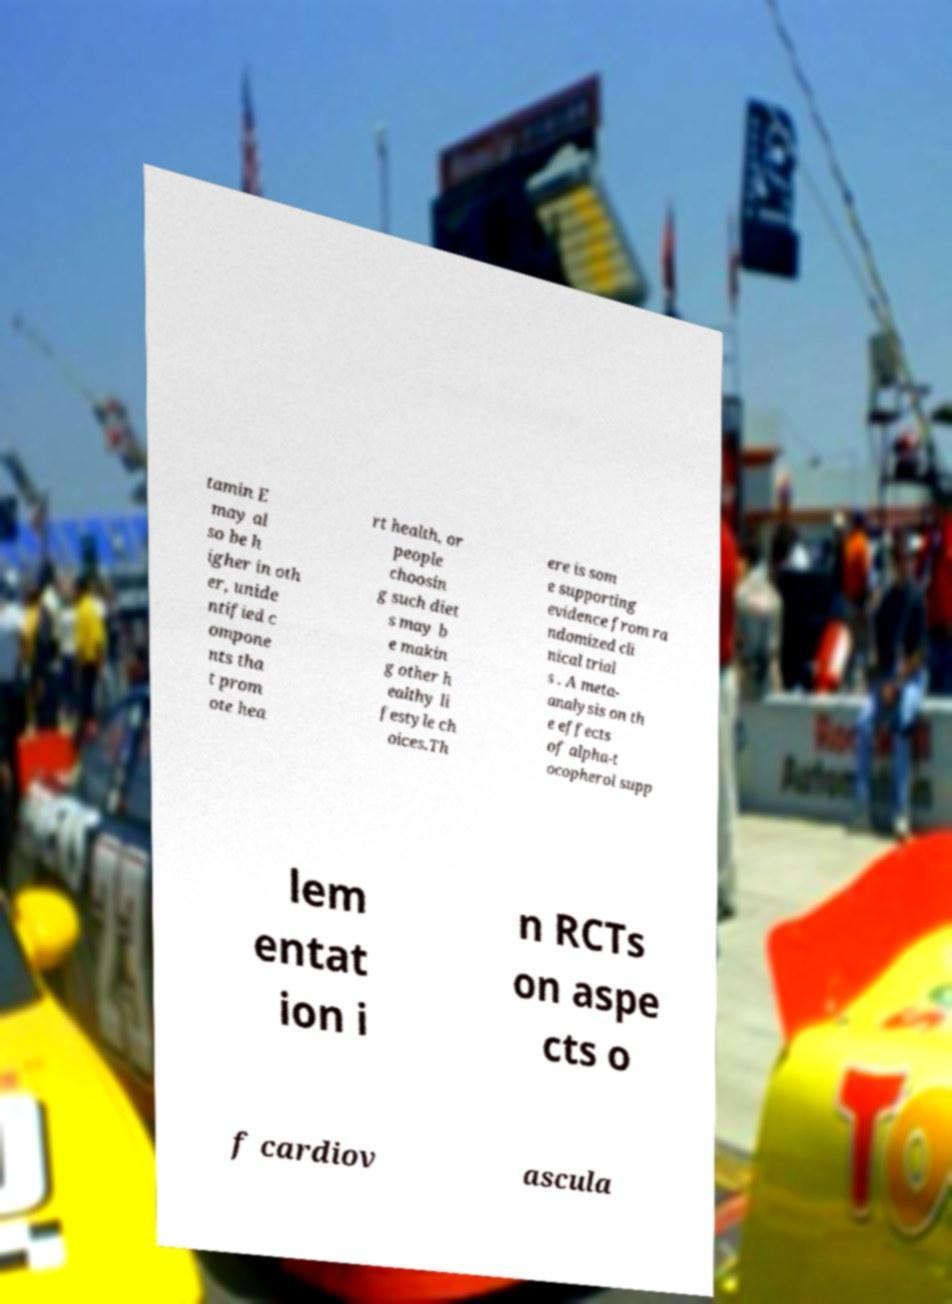For documentation purposes, I need the text within this image transcribed. Could you provide that? tamin E may al so be h igher in oth er, unide ntified c ompone nts tha t prom ote hea rt health, or people choosin g such diet s may b e makin g other h ealthy li festyle ch oices.Th ere is som e supporting evidence from ra ndomized cli nical trial s . A meta- analysis on th e effects of alpha-t ocopherol supp lem entat ion i n RCTs on aspe cts o f cardiov ascula 